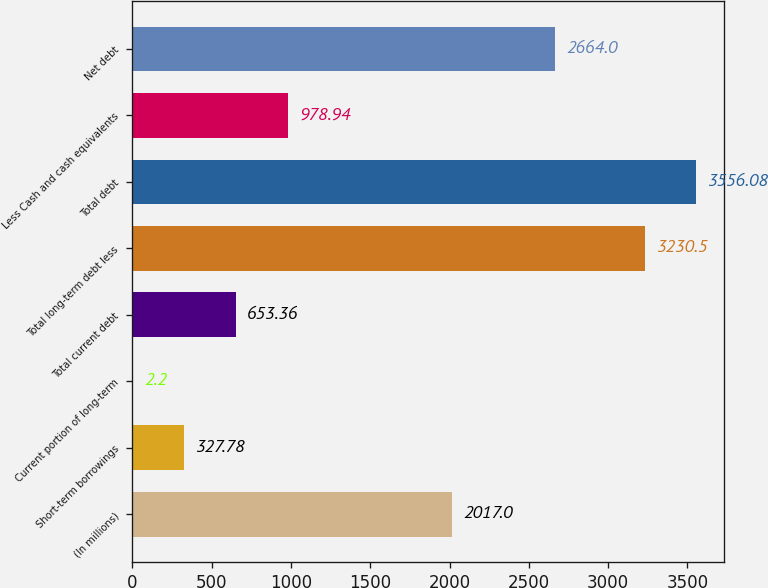Convert chart to OTSL. <chart><loc_0><loc_0><loc_500><loc_500><bar_chart><fcel>(In millions)<fcel>Short-term borrowings<fcel>Current portion of long-term<fcel>Total current debt<fcel>Total long-term debt less<fcel>Total debt<fcel>Less Cash and cash equivalents<fcel>Net debt<nl><fcel>2017<fcel>327.78<fcel>2.2<fcel>653.36<fcel>3230.5<fcel>3556.08<fcel>978.94<fcel>2664<nl></chart> 